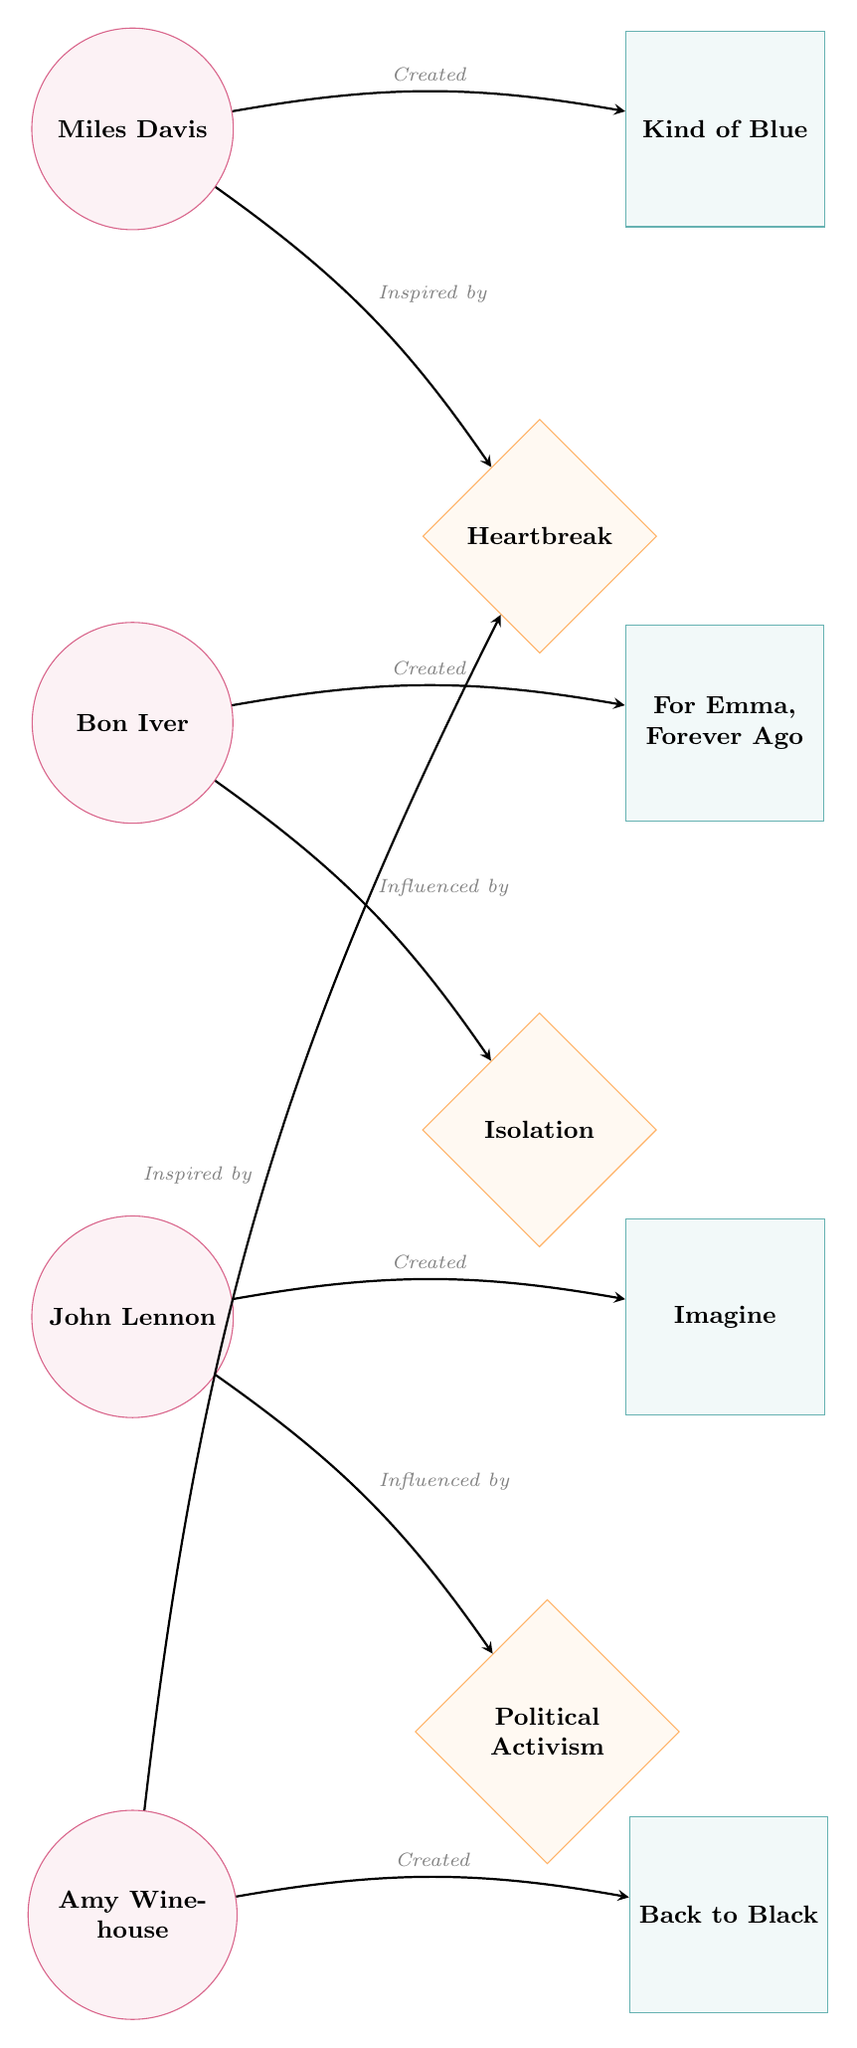What artist created "Kind of Blue"? The diagram shows an edge labeled "Created" between Miles Davis and Kind of Blue. This indicates that Miles Davis is the artist who created the work "Kind of Blue."
Answer: Miles Davis What influenced Bon Iver? The diagram has an edge labeled "Influenced by" leading from Bon Iver to Isolation. This indicates that Bon Iver was influenced by the experience of isolation.
Answer: Isolation Which work did John Lennon create? In the diagram, there is an edge labeled "Created" connecting John Lennon and the work Imagine. This indicates that John Lennon is the creator of the work Imagine.
Answer: Imagine How many artists are depicted in the diagram? The diagram includes four artist nodes: Miles Davis, Bon Iver, John Lennon, and Amy Winehouse. Counting these nodes gives a total of four artists represented.
Answer: 4 What emotional experience is shared between Miles Davis and Amy Winehouse? The diagram shows an edge labeled "Inspired by" from both Miles Davis and Amy Winehouse to the experience of Heartbreak. This indicates that both artists have a connection through this emotional experience.
Answer: Heartbreak Which artist has a work titled "Back to Black"? In the diagram, the edge labeled "Created" connects Amy Winehouse to the work Back to Black. This indicates that Amy Winehouse is the artist associated with this work.
Answer: Back to Black What relationship does John Lennon have with Political Activism? The diagram includes an edge labeled "Influenced by" that connects John Lennon to Political Activism. This indicates the relationship where Political Activism is seen as an influence on John Lennon.
Answer: Influenced by Which two artists have connections to Heartbreak? The diagram shows that both Miles Davis and Amy Winehouse have edges leading to Heartbreak. Thus, both artists are connected to this emotional experience.
Answer: Miles Davis and Amy Winehouse How many connections (edges) are there in total in the diagram? By observing the edges present, there are a total of eight connections represented in the diagram among the artists and their works.
Answer: 8 